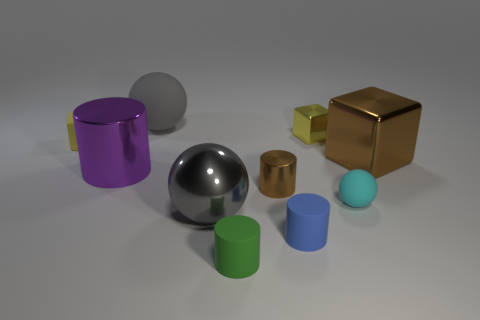Subtract all balls. How many objects are left? 7 Add 6 small cyan cylinders. How many small cyan cylinders exist? 6 Subtract 0 blue blocks. How many objects are left? 10 Subtract all metallic balls. Subtract all red spheres. How many objects are left? 9 Add 6 small blue rubber things. How many small blue rubber things are left? 7 